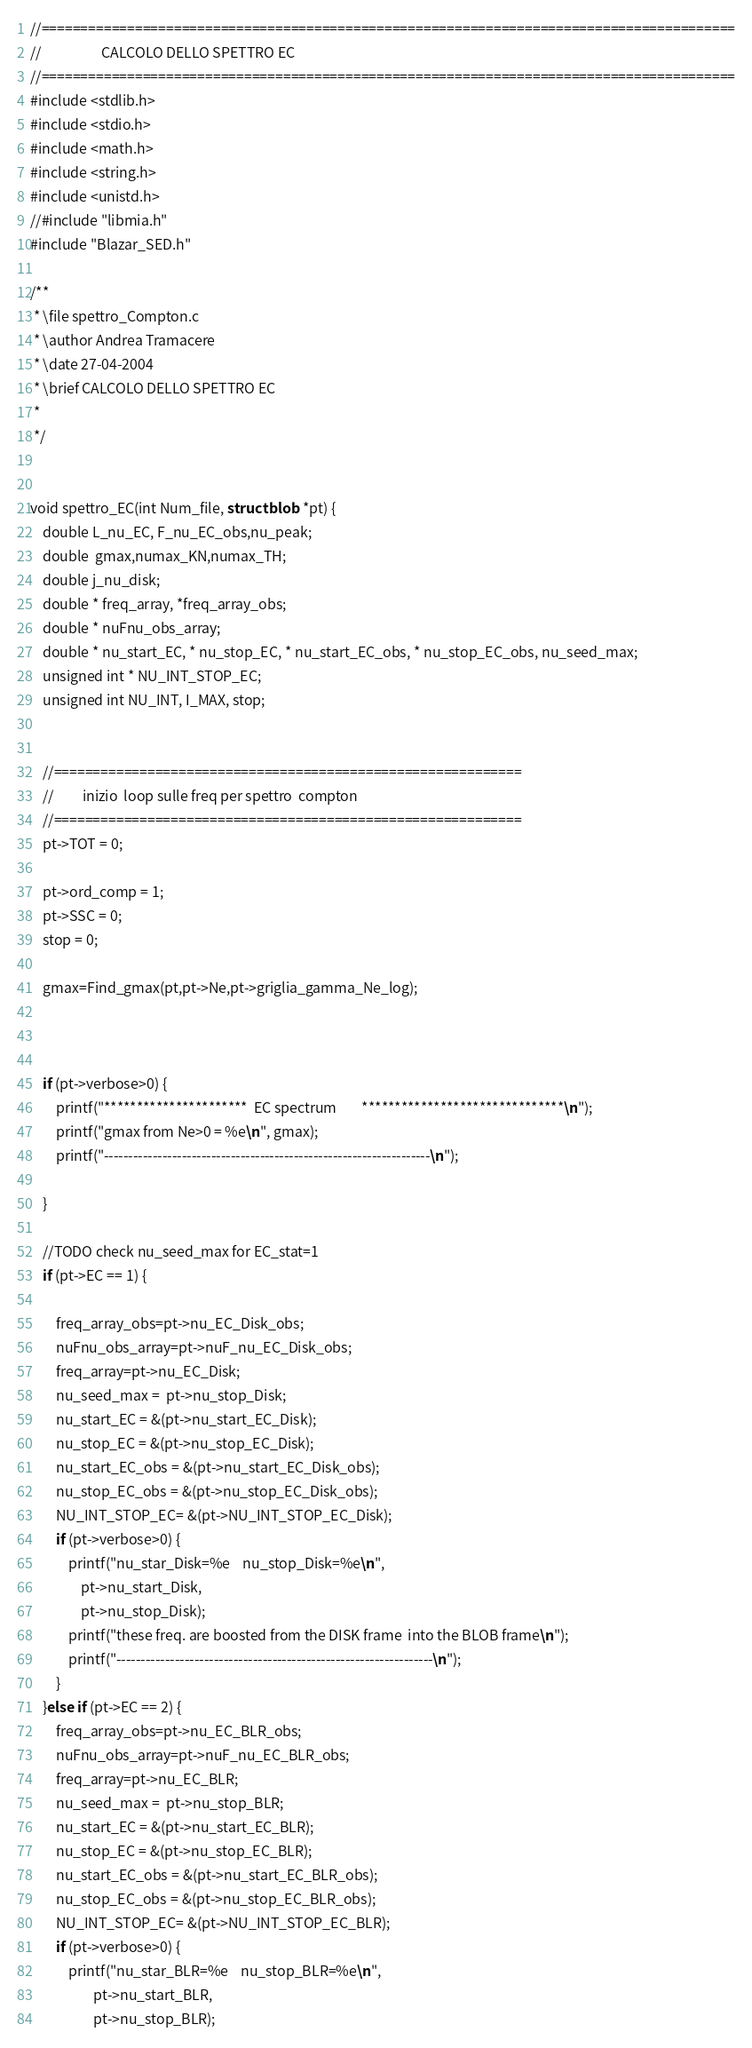<code> <loc_0><loc_0><loc_500><loc_500><_C_>//=========================================================================================
//                   CALCOLO DELLO SPETTRO EC
//=========================================================================================
#include <stdlib.h>
#include <stdio.h>
#include <math.h>
#include <string.h>
#include <unistd.h>
//#include "libmia.h"
#include "Blazar_SED.h"

/**
 * \file spettro_Compton.c
 * \author Andrea Tramacere
 * \date 27-04-2004
 * \brief CALCOLO DELLO SPETTRO EC
 *
 */


void spettro_EC(int Num_file, struct blob *pt) {
    double L_nu_EC, F_nu_EC_obs,nu_peak;
    double  gmax,numax_KN,numax_TH;
    double j_nu_disk;
    double * freq_array, *freq_array_obs;
    double * nuFnu_obs_array;
    double * nu_start_EC, * nu_stop_EC, * nu_start_EC_obs, * nu_stop_EC_obs, nu_seed_max;
    unsigned int * NU_INT_STOP_EC;
    unsigned int NU_INT, I_MAX, stop;
    

    //============================================================
    //         inizio  loop sulle freq per spettro  compton
    //============================================================
    pt->TOT = 0;

    pt->ord_comp = 1;
    pt->SSC = 0;
    stop = 0;

    gmax=Find_gmax(pt,pt->Ne,pt->griglia_gamma_Ne_log);



    if (pt->verbose>0) {
    	printf("**********************  EC spectrum        *******************************\n");
    	printf("gmax from Ne>0 = %e\n", gmax);
        printf("-------------------------------------------------------------------\n");

    }

	//TODO check nu_seed_max for EC_stat=1
	if (pt->EC == 1) {

    	freq_array_obs=pt->nu_EC_Disk_obs;
    	nuFnu_obs_array=pt->nuF_nu_EC_Disk_obs;
    	freq_array=pt->nu_EC_Disk;
    	nu_seed_max =  pt->nu_stop_Disk;
    	nu_start_EC = &(pt->nu_start_EC_Disk);
    	nu_stop_EC = &(pt->nu_stop_EC_Disk);
		nu_start_EC_obs = &(pt->nu_start_EC_Disk_obs);
    	nu_stop_EC_obs = &(pt->nu_stop_EC_Disk_obs);
    	NU_INT_STOP_EC= &(pt->NU_INT_STOP_EC_Disk);
    	if (pt->verbose>0) {
    		printf("nu_star_Disk=%e    nu_stop_Disk=%e\n",
    			pt->nu_start_Disk,
    			pt->nu_stop_Disk);
    		printf("these freq. are boosted from the DISK frame  into the BLOB frame\n");
    		printf("-----------------------------------------------------------------\n");
    	}
    }else if (pt->EC == 2) {
    	freq_array_obs=pt->nu_EC_BLR_obs;
    	nuFnu_obs_array=pt->nuF_nu_EC_BLR_obs;
    	freq_array=pt->nu_EC_BLR;
    	nu_seed_max =  pt->nu_stop_BLR;
    	nu_start_EC = &(pt->nu_start_EC_BLR);
    	nu_stop_EC = &(pt->nu_stop_EC_BLR);
    	nu_start_EC_obs = &(pt->nu_start_EC_BLR_obs);
    	nu_stop_EC_obs = &(pt->nu_stop_EC_BLR_obs);
    	NU_INT_STOP_EC= &(pt->NU_INT_STOP_EC_BLR);
    	if (pt->verbose>0) {
			printf("nu_star_BLR=%e    nu_stop_BLR=%e\n",
					pt->nu_start_BLR,
					pt->nu_stop_BLR);</code> 